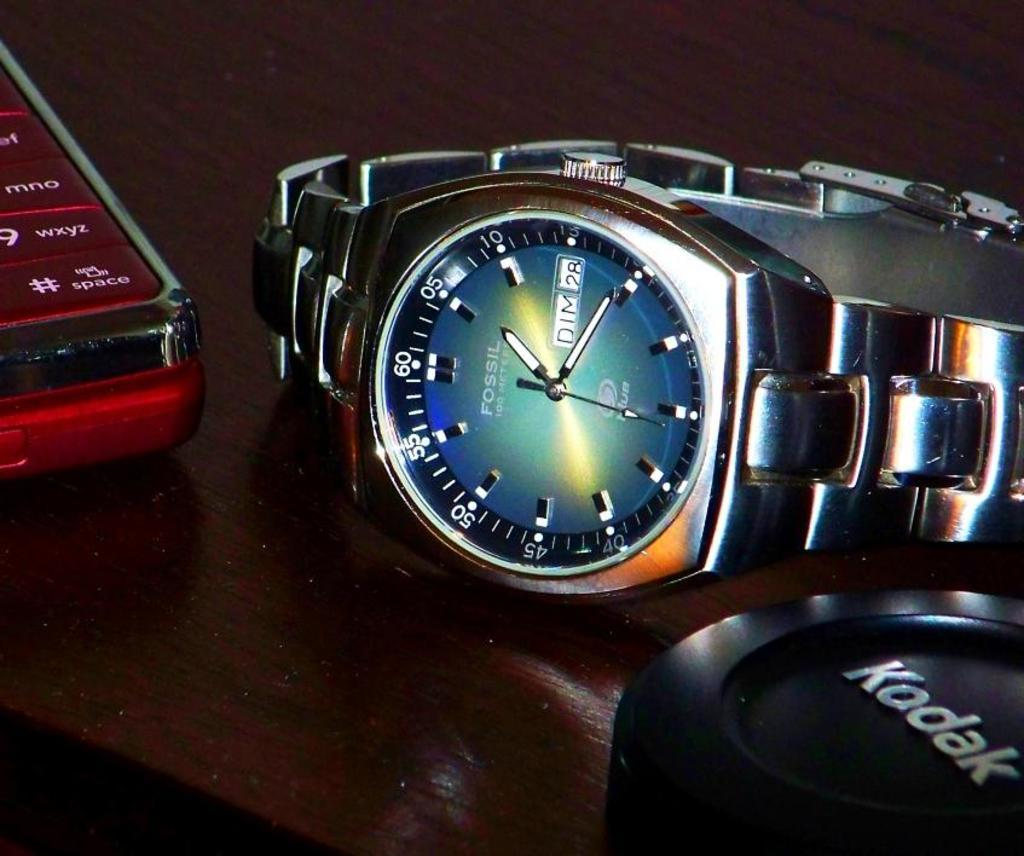<image>
Give a short and clear explanation of the subsequent image. A Fossil watch is laying on its side next to a red cell phone. 